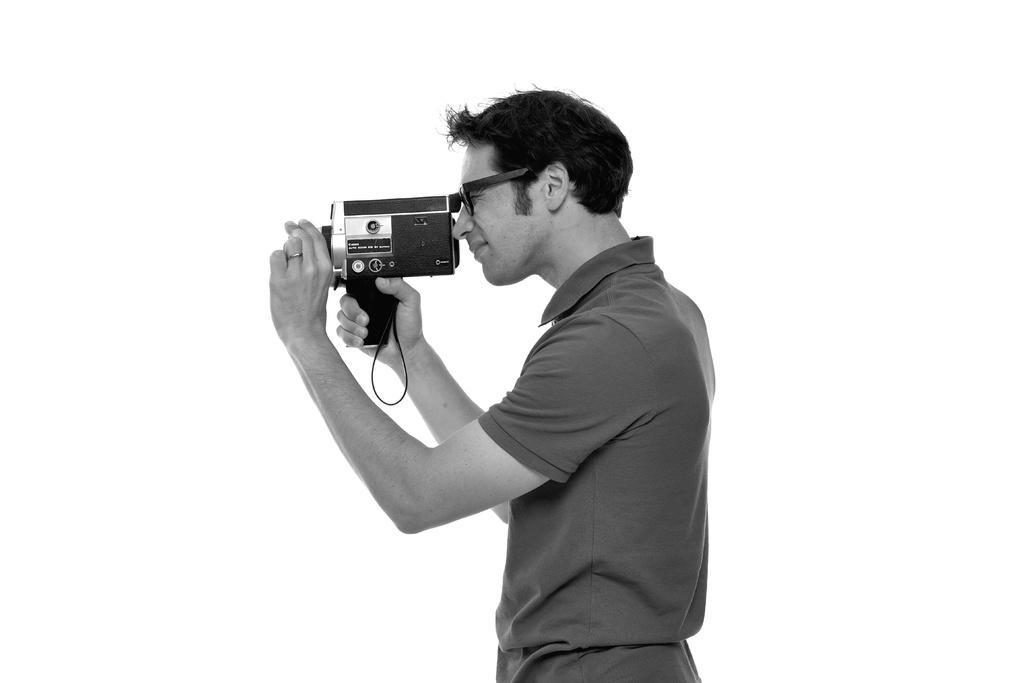Could you give a brief overview of what you see in this image? In this picture we can see man wore spectacle, T-Shirt and holding camera in his hand and taking picture and in background it is white in color. 